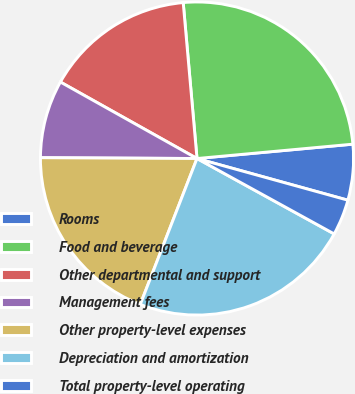<chart> <loc_0><loc_0><loc_500><loc_500><pie_chart><fcel>Rooms<fcel>Food and beverage<fcel>Other departmental and support<fcel>Management fees<fcel>Other property-level expenses<fcel>Depreciation and amortization<fcel>Total property-level operating<nl><fcel>5.75%<fcel>24.94%<fcel>15.47%<fcel>8.04%<fcel>19.18%<fcel>22.9%<fcel>3.71%<nl></chart> 